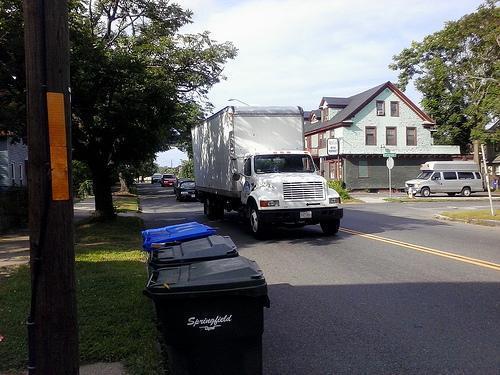How many garbage containers are there?
Give a very brief answer. 3. How many trash cans are on the street curb?
Give a very brief answer. 3. How many people boats are in the picture?
Give a very brief answer. 0. How many elephants are pictured?
Give a very brief answer. 0. How many dinosaurs are in the picture?
Give a very brief answer. 0. 